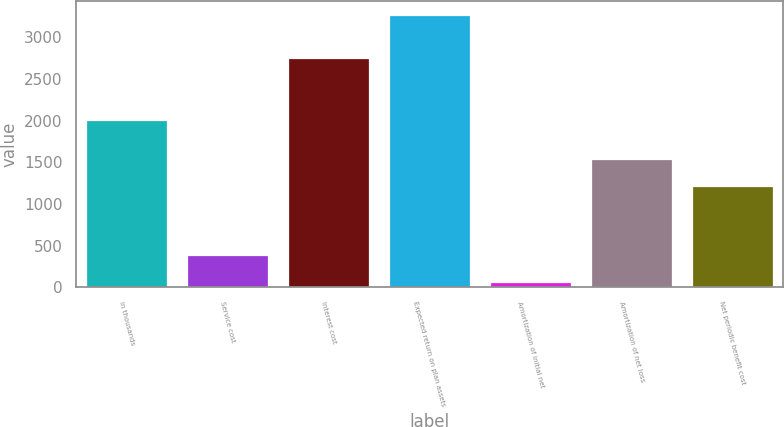<chart> <loc_0><loc_0><loc_500><loc_500><bar_chart><fcel>In thousands<fcel>Service cost<fcel>Interest cost<fcel>Expected return on plan assets<fcel>Amortization of initial net<fcel>Amortization of net loss<fcel>Net periodic benefit cost<nl><fcel>2009<fcel>382.7<fcel>2745<fcel>3269<fcel>62<fcel>1532.7<fcel>1212<nl></chart> 